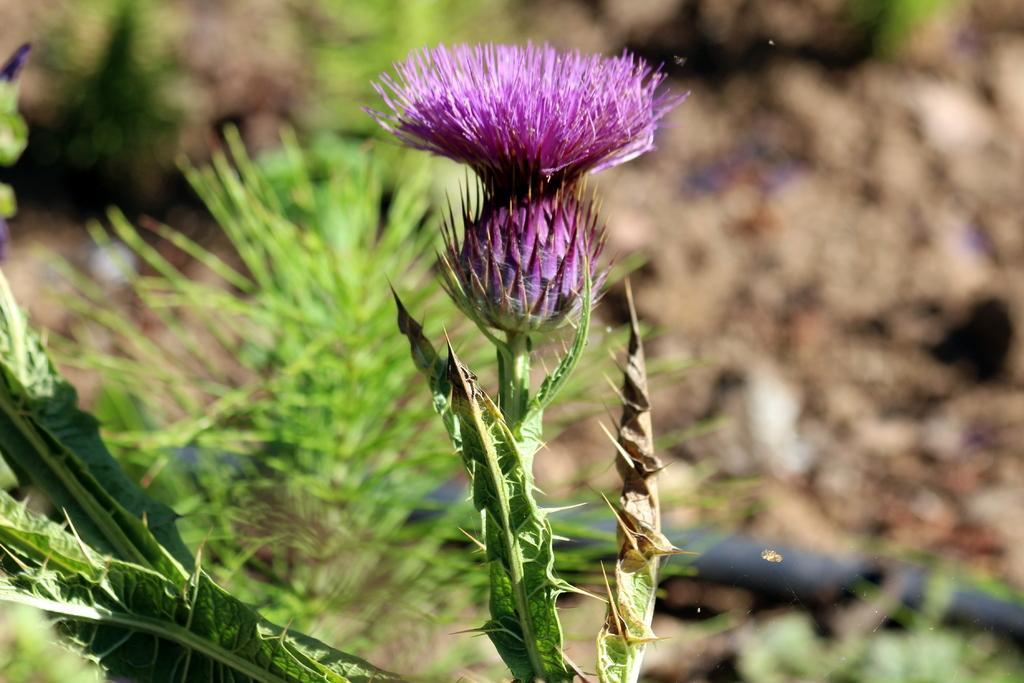Please provide a concise description of this image. In this image I can see the flower in purple color. In the background I can see few plants in green color. 